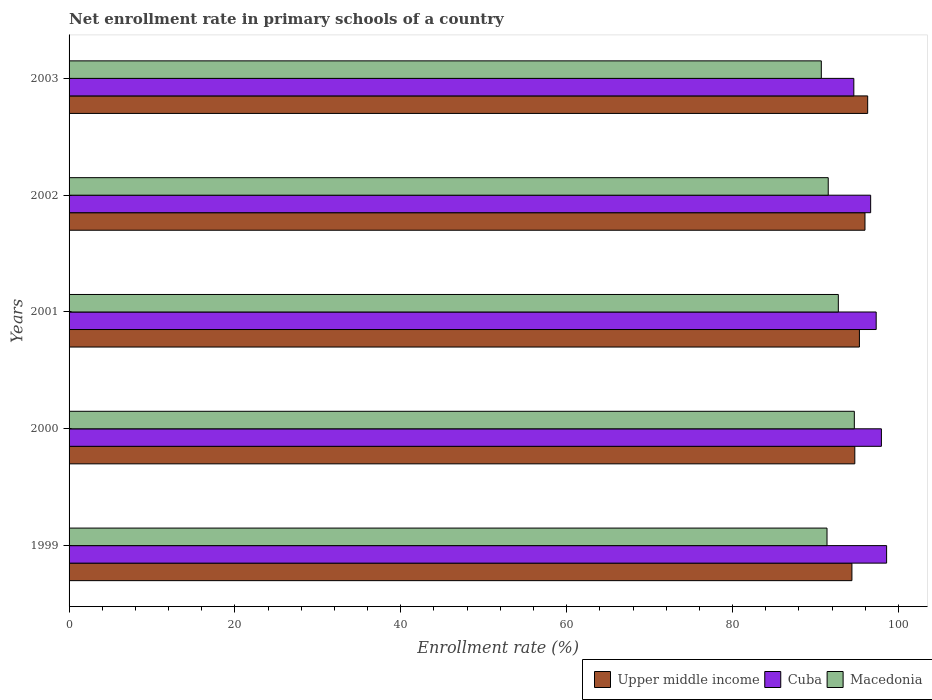How many different coloured bars are there?
Your response must be concise. 3. Are the number of bars per tick equal to the number of legend labels?
Your response must be concise. Yes. How many bars are there on the 3rd tick from the top?
Your response must be concise. 3. How many bars are there on the 4th tick from the bottom?
Ensure brevity in your answer.  3. What is the enrollment rate in primary schools in Macedonia in 2002?
Keep it short and to the point. 91.54. Across all years, what is the maximum enrollment rate in primary schools in Cuba?
Your response must be concise. 98.58. Across all years, what is the minimum enrollment rate in primary schools in Cuba?
Offer a very short reply. 94.62. In which year was the enrollment rate in primary schools in Upper middle income maximum?
Ensure brevity in your answer.  2003. In which year was the enrollment rate in primary schools in Cuba minimum?
Provide a succinct answer. 2003. What is the total enrollment rate in primary schools in Cuba in the graph?
Your response must be concise. 485.12. What is the difference between the enrollment rate in primary schools in Macedonia in 2001 and that in 2003?
Your response must be concise. 2.05. What is the difference between the enrollment rate in primary schools in Macedonia in 2000 and the enrollment rate in primary schools in Cuba in 2002?
Give a very brief answer. -1.97. What is the average enrollment rate in primary schools in Cuba per year?
Your answer should be very brief. 97.02. In the year 2001, what is the difference between the enrollment rate in primary schools in Macedonia and enrollment rate in primary schools in Cuba?
Provide a short and direct response. -4.57. In how many years, is the enrollment rate in primary schools in Macedonia greater than 64 %?
Offer a terse response. 5. What is the ratio of the enrollment rate in primary schools in Upper middle income in 2002 to that in 2003?
Your response must be concise. 1. Is the difference between the enrollment rate in primary schools in Macedonia in 1999 and 2001 greater than the difference between the enrollment rate in primary schools in Cuba in 1999 and 2001?
Your response must be concise. No. What is the difference between the highest and the second highest enrollment rate in primary schools in Macedonia?
Your answer should be very brief. 1.93. What is the difference between the highest and the lowest enrollment rate in primary schools in Macedonia?
Your response must be concise. 3.98. Is the sum of the enrollment rate in primary schools in Upper middle income in 2000 and 2002 greater than the maximum enrollment rate in primary schools in Cuba across all years?
Give a very brief answer. Yes. What does the 2nd bar from the top in 1999 represents?
Give a very brief answer. Cuba. What does the 1st bar from the bottom in 2003 represents?
Give a very brief answer. Upper middle income. How many bars are there?
Keep it short and to the point. 15. Are all the bars in the graph horizontal?
Ensure brevity in your answer.  Yes. What is the difference between two consecutive major ticks on the X-axis?
Offer a terse response. 20. Does the graph contain any zero values?
Your answer should be compact. No. Does the graph contain grids?
Your answer should be compact. No. Where does the legend appear in the graph?
Make the answer very short. Bottom right. What is the title of the graph?
Your answer should be compact. Net enrollment rate in primary schools of a country. Does "Middle income" appear as one of the legend labels in the graph?
Provide a succinct answer. No. What is the label or title of the X-axis?
Provide a succinct answer. Enrollment rate (%). What is the label or title of the Y-axis?
Your response must be concise. Years. What is the Enrollment rate (%) of Upper middle income in 1999?
Your response must be concise. 94.39. What is the Enrollment rate (%) of Cuba in 1999?
Make the answer very short. 98.58. What is the Enrollment rate (%) in Macedonia in 1999?
Provide a succinct answer. 91.39. What is the Enrollment rate (%) in Upper middle income in 2000?
Provide a short and direct response. 94.74. What is the Enrollment rate (%) of Cuba in 2000?
Give a very brief answer. 97.95. What is the Enrollment rate (%) in Macedonia in 2000?
Offer a very short reply. 94.68. What is the Enrollment rate (%) of Upper middle income in 2001?
Your answer should be very brief. 95.3. What is the Enrollment rate (%) of Cuba in 2001?
Your answer should be compact. 97.32. What is the Enrollment rate (%) in Macedonia in 2001?
Provide a short and direct response. 92.75. What is the Enrollment rate (%) of Upper middle income in 2002?
Make the answer very short. 95.97. What is the Enrollment rate (%) in Cuba in 2002?
Offer a very short reply. 96.65. What is the Enrollment rate (%) in Macedonia in 2002?
Give a very brief answer. 91.54. What is the Enrollment rate (%) of Upper middle income in 2003?
Ensure brevity in your answer.  96.29. What is the Enrollment rate (%) in Cuba in 2003?
Your response must be concise. 94.62. What is the Enrollment rate (%) in Macedonia in 2003?
Make the answer very short. 90.7. Across all years, what is the maximum Enrollment rate (%) in Upper middle income?
Offer a very short reply. 96.29. Across all years, what is the maximum Enrollment rate (%) in Cuba?
Give a very brief answer. 98.58. Across all years, what is the maximum Enrollment rate (%) in Macedonia?
Make the answer very short. 94.68. Across all years, what is the minimum Enrollment rate (%) of Upper middle income?
Ensure brevity in your answer.  94.39. Across all years, what is the minimum Enrollment rate (%) in Cuba?
Your answer should be very brief. 94.62. Across all years, what is the minimum Enrollment rate (%) of Macedonia?
Make the answer very short. 90.7. What is the total Enrollment rate (%) of Upper middle income in the graph?
Your answer should be very brief. 476.7. What is the total Enrollment rate (%) of Cuba in the graph?
Your answer should be compact. 485.12. What is the total Enrollment rate (%) in Macedonia in the graph?
Your answer should be compact. 461.07. What is the difference between the Enrollment rate (%) in Upper middle income in 1999 and that in 2000?
Give a very brief answer. -0.35. What is the difference between the Enrollment rate (%) in Cuba in 1999 and that in 2000?
Offer a very short reply. 0.63. What is the difference between the Enrollment rate (%) of Macedonia in 1999 and that in 2000?
Give a very brief answer. -3.29. What is the difference between the Enrollment rate (%) in Upper middle income in 1999 and that in 2001?
Offer a terse response. -0.9. What is the difference between the Enrollment rate (%) in Cuba in 1999 and that in 2001?
Your answer should be compact. 1.26. What is the difference between the Enrollment rate (%) of Macedonia in 1999 and that in 2001?
Offer a very short reply. -1.36. What is the difference between the Enrollment rate (%) in Upper middle income in 1999 and that in 2002?
Your answer should be very brief. -1.58. What is the difference between the Enrollment rate (%) of Cuba in 1999 and that in 2002?
Make the answer very short. 1.92. What is the difference between the Enrollment rate (%) of Macedonia in 1999 and that in 2002?
Give a very brief answer. -0.15. What is the difference between the Enrollment rate (%) of Upper middle income in 1999 and that in 2003?
Your answer should be compact. -1.9. What is the difference between the Enrollment rate (%) in Cuba in 1999 and that in 2003?
Make the answer very short. 3.95. What is the difference between the Enrollment rate (%) in Macedonia in 1999 and that in 2003?
Offer a very short reply. 0.69. What is the difference between the Enrollment rate (%) of Upper middle income in 2000 and that in 2001?
Your answer should be compact. -0.55. What is the difference between the Enrollment rate (%) in Cuba in 2000 and that in 2001?
Make the answer very short. 0.63. What is the difference between the Enrollment rate (%) of Macedonia in 2000 and that in 2001?
Provide a short and direct response. 1.93. What is the difference between the Enrollment rate (%) in Upper middle income in 2000 and that in 2002?
Your answer should be compact. -1.23. What is the difference between the Enrollment rate (%) of Cuba in 2000 and that in 2002?
Provide a short and direct response. 1.29. What is the difference between the Enrollment rate (%) in Macedonia in 2000 and that in 2002?
Your answer should be compact. 3.15. What is the difference between the Enrollment rate (%) of Upper middle income in 2000 and that in 2003?
Your response must be concise. -1.55. What is the difference between the Enrollment rate (%) of Cuba in 2000 and that in 2003?
Offer a terse response. 3.33. What is the difference between the Enrollment rate (%) in Macedonia in 2000 and that in 2003?
Offer a terse response. 3.98. What is the difference between the Enrollment rate (%) in Upper middle income in 2001 and that in 2002?
Make the answer very short. -0.67. What is the difference between the Enrollment rate (%) of Cuba in 2001 and that in 2002?
Provide a succinct answer. 0.67. What is the difference between the Enrollment rate (%) in Macedonia in 2001 and that in 2002?
Your response must be concise. 1.22. What is the difference between the Enrollment rate (%) in Upper middle income in 2001 and that in 2003?
Provide a succinct answer. -1. What is the difference between the Enrollment rate (%) in Cuba in 2001 and that in 2003?
Keep it short and to the point. 2.7. What is the difference between the Enrollment rate (%) in Macedonia in 2001 and that in 2003?
Keep it short and to the point. 2.05. What is the difference between the Enrollment rate (%) in Upper middle income in 2002 and that in 2003?
Make the answer very short. -0.32. What is the difference between the Enrollment rate (%) of Cuba in 2002 and that in 2003?
Offer a very short reply. 2.03. What is the difference between the Enrollment rate (%) of Macedonia in 2002 and that in 2003?
Provide a short and direct response. 0.83. What is the difference between the Enrollment rate (%) of Upper middle income in 1999 and the Enrollment rate (%) of Cuba in 2000?
Offer a very short reply. -3.55. What is the difference between the Enrollment rate (%) in Upper middle income in 1999 and the Enrollment rate (%) in Macedonia in 2000?
Keep it short and to the point. -0.29. What is the difference between the Enrollment rate (%) in Cuba in 1999 and the Enrollment rate (%) in Macedonia in 2000?
Give a very brief answer. 3.89. What is the difference between the Enrollment rate (%) in Upper middle income in 1999 and the Enrollment rate (%) in Cuba in 2001?
Your answer should be very brief. -2.93. What is the difference between the Enrollment rate (%) of Upper middle income in 1999 and the Enrollment rate (%) of Macedonia in 2001?
Your answer should be very brief. 1.64. What is the difference between the Enrollment rate (%) of Cuba in 1999 and the Enrollment rate (%) of Macedonia in 2001?
Make the answer very short. 5.82. What is the difference between the Enrollment rate (%) in Upper middle income in 1999 and the Enrollment rate (%) in Cuba in 2002?
Provide a succinct answer. -2.26. What is the difference between the Enrollment rate (%) of Upper middle income in 1999 and the Enrollment rate (%) of Macedonia in 2002?
Offer a very short reply. 2.86. What is the difference between the Enrollment rate (%) of Cuba in 1999 and the Enrollment rate (%) of Macedonia in 2002?
Your answer should be very brief. 7.04. What is the difference between the Enrollment rate (%) of Upper middle income in 1999 and the Enrollment rate (%) of Cuba in 2003?
Make the answer very short. -0.23. What is the difference between the Enrollment rate (%) in Upper middle income in 1999 and the Enrollment rate (%) in Macedonia in 2003?
Provide a succinct answer. 3.69. What is the difference between the Enrollment rate (%) in Cuba in 1999 and the Enrollment rate (%) in Macedonia in 2003?
Make the answer very short. 7.87. What is the difference between the Enrollment rate (%) in Upper middle income in 2000 and the Enrollment rate (%) in Cuba in 2001?
Provide a short and direct response. -2.58. What is the difference between the Enrollment rate (%) of Upper middle income in 2000 and the Enrollment rate (%) of Macedonia in 2001?
Provide a succinct answer. 1.99. What is the difference between the Enrollment rate (%) of Cuba in 2000 and the Enrollment rate (%) of Macedonia in 2001?
Your answer should be very brief. 5.19. What is the difference between the Enrollment rate (%) in Upper middle income in 2000 and the Enrollment rate (%) in Cuba in 2002?
Your answer should be compact. -1.91. What is the difference between the Enrollment rate (%) in Upper middle income in 2000 and the Enrollment rate (%) in Macedonia in 2002?
Provide a short and direct response. 3.21. What is the difference between the Enrollment rate (%) of Cuba in 2000 and the Enrollment rate (%) of Macedonia in 2002?
Provide a succinct answer. 6.41. What is the difference between the Enrollment rate (%) in Upper middle income in 2000 and the Enrollment rate (%) in Cuba in 2003?
Keep it short and to the point. 0.12. What is the difference between the Enrollment rate (%) of Upper middle income in 2000 and the Enrollment rate (%) of Macedonia in 2003?
Offer a terse response. 4.04. What is the difference between the Enrollment rate (%) in Cuba in 2000 and the Enrollment rate (%) in Macedonia in 2003?
Your response must be concise. 7.24. What is the difference between the Enrollment rate (%) in Upper middle income in 2001 and the Enrollment rate (%) in Cuba in 2002?
Offer a very short reply. -1.36. What is the difference between the Enrollment rate (%) in Upper middle income in 2001 and the Enrollment rate (%) in Macedonia in 2002?
Provide a succinct answer. 3.76. What is the difference between the Enrollment rate (%) in Cuba in 2001 and the Enrollment rate (%) in Macedonia in 2002?
Provide a succinct answer. 5.78. What is the difference between the Enrollment rate (%) of Upper middle income in 2001 and the Enrollment rate (%) of Cuba in 2003?
Your answer should be compact. 0.67. What is the difference between the Enrollment rate (%) of Upper middle income in 2001 and the Enrollment rate (%) of Macedonia in 2003?
Your answer should be compact. 4.59. What is the difference between the Enrollment rate (%) of Cuba in 2001 and the Enrollment rate (%) of Macedonia in 2003?
Make the answer very short. 6.62. What is the difference between the Enrollment rate (%) of Upper middle income in 2002 and the Enrollment rate (%) of Cuba in 2003?
Your answer should be compact. 1.35. What is the difference between the Enrollment rate (%) in Upper middle income in 2002 and the Enrollment rate (%) in Macedonia in 2003?
Ensure brevity in your answer.  5.27. What is the difference between the Enrollment rate (%) in Cuba in 2002 and the Enrollment rate (%) in Macedonia in 2003?
Ensure brevity in your answer.  5.95. What is the average Enrollment rate (%) in Upper middle income per year?
Provide a succinct answer. 95.34. What is the average Enrollment rate (%) of Cuba per year?
Your answer should be compact. 97.02. What is the average Enrollment rate (%) in Macedonia per year?
Provide a short and direct response. 92.21. In the year 1999, what is the difference between the Enrollment rate (%) of Upper middle income and Enrollment rate (%) of Cuba?
Provide a succinct answer. -4.18. In the year 1999, what is the difference between the Enrollment rate (%) of Upper middle income and Enrollment rate (%) of Macedonia?
Give a very brief answer. 3. In the year 1999, what is the difference between the Enrollment rate (%) of Cuba and Enrollment rate (%) of Macedonia?
Your answer should be very brief. 7.19. In the year 2000, what is the difference between the Enrollment rate (%) in Upper middle income and Enrollment rate (%) in Cuba?
Your response must be concise. -3.21. In the year 2000, what is the difference between the Enrollment rate (%) in Upper middle income and Enrollment rate (%) in Macedonia?
Offer a terse response. 0.06. In the year 2000, what is the difference between the Enrollment rate (%) of Cuba and Enrollment rate (%) of Macedonia?
Offer a very short reply. 3.26. In the year 2001, what is the difference between the Enrollment rate (%) of Upper middle income and Enrollment rate (%) of Cuba?
Make the answer very short. -2.02. In the year 2001, what is the difference between the Enrollment rate (%) of Upper middle income and Enrollment rate (%) of Macedonia?
Offer a terse response. 2.54. In the year 2001, what is the difference between the Enrollment rate (%) of Cuba and Enrollment rate (%) of Macedonia?
Your answer should be very brief. 4.57. In the year 2002, what is the difference between the Enrollment rate (%) of Upper middle income and Enrollment rate (%) of Cuba?
Offer a very short reply. -0.68. In the year 2002, what is the difference between the Enrollment rate (%) in Upper middle income and Enrollment rate (%) in Macedonia?
Offer a very short reply. 4.43. In the year 2002, what is the difference between the Enrollment rate (%) of Cuba and Enrollment rate (%) of Macedonia?
Offer a very short reply. 5.12. In the year 2003, what is the difference between the Enrollment rate (%) of Upper middle income and Enrollment rate (%) of Cuba?
Provide a short and direct response. 1.67. In the year 2003, what is the difference between the Enrollment rate (%) in Upper middle income and Enrollment rate (%) in Macedonia?
Provide a short and direct response. 5.59. In the year 2003, what is the difference between the Enrollment rate (%) in Cuba and Enrollment rate (%) in Macedonia?
Offer a terse response. 3.92. What is the ratio of the Enrollment rate (%) of Upper middle income in 1999 to that in 2000?
Your answer should be very brief. 1. What is the ratio of the Enrollment rate (%) in Cuba in 1999 to that in 2000?
Give a very brief answer. 1.01. What is the ratio of the Enrollment rate (%) in Macedonia in 1999 to that in 2000?
Ensure brevity in your answer.  0.97. What is the ratio of the Enrollment rate (%) in Upper middle income in 1999 to that in 2001?
Offer a very short reply. 0.99. What is the ratio of the Enrollment rate (%) in Cuba in 1999 to that in 2001?
Your answer should be very brief. 1.01. What is the ratio of the Enrollment rate (%) of Upper middle income in 1999 to that in 2002?
Ensure brevity in your answer.  0.98. What is the ratio of the Enrollment rate (%) in Cuba in 1999 to that in 2002?
Make the answer very short. 1.02. What is the ratio of the Enrollment rate (%) of Macedonia in 1999 to that in 2002?
Provide a succinct answer. 1. What is the ratio of the Enrollment rate (%) of Upper middle income in 1999 to that in 2003?
Give a very brief answer. 0.98. What is the ratio of the Enrollment rate (%) of Cuba in 1999 to that in 2003?
Give a very brief answer. 1.04. What is the ratio of the Enrollment rate (%) of Macedonia in 1999 to that in 2003?
Keep it short and to the point. 1.01. What is the ratio of the Enrollment rate (%) in Upper middle income in 2000 to that in 2001?
Make the answer very short. 0.99. What is the ratio of the Enrollment rate (%) of Macedonia in 2000 to that in 2001?
Your answer should be compact. 1.02. What is the ratio of the Enrollment rate (%) of Upper middle income in 2000 to that in 2002?
Your response must be concise. 0.99. What is the ratio of the Enrollment rate (%) in Cuba in 2000 to that in 2002?
Offer a very short reply. 1.01. What is the ratio of the Enrollment rate (%) in Macedonia in 2000 to that in 2002?
Give a very brief answer. 1.03. What is the ratio of the Enrollment rate (%) in Upper middle income in 2000 to that in 2003?
Keep it short and to the point. 0.98. What is the ratio of the Enrollment rate (%) of Cuba in 2000 to that in 2003?
Keep it short and to the point. 1.04. What is the ratio of the Enrollment rate (%) of Macedonia in 2000 to that in 2003?
Offer a terse response. 1.04. What is the ratio of the Enrollment rate (%) in Upper middle income in 2001 to that in 2002?
Provide a succinct answer. 0.99. What is the ratio of the Enrollment rate (%) in Macedonia in 2001 to that in 2002?
Provide a succinct answer. 1.01. What is the ratio of the Enrollment rate (%) of Cuba in 2001 to that in 2003?
Your answer should be compact. 1.03. What is the ratio of the Enrollment rate (%) in Macedonia in 2001 to that in 2003?
Offer a terse response. 1.02. What is the ratio of the Enrollment rate (%) of Upper middle income in 2002 to that in 2003?
Provide a succinct answer. 1. What is the ratio of the Enrollment rate (%) of Cuba in 2002 to that in 2003?
Your answer should be very brief. 1.02. What is the ratio of the Enrollment rate (%) of Macedonia in 2002 to that in 2003?
Offer a terse response. 1.01. What is the difference between the highest and the second highest Enrollment rate (%) in Upper middle income?
Your answer should be compact. 0.32. What is the difference between the highest and the second highest Enrollment rate (%) in Cuba?
Provide a succinct answer. 0.63. What is the difference between the highest and the second highest Enrollment rate (%) in Macedonia?
Ensure brevity in your answer.  1.93. What is the difference between the highest and the lowest Enrollment rate (%) of Cuba?
Ensure brevity in your answer.  3.95. What is the difference between the highest and the lowest Enrollment rate (%) of Macedonia?
Offer a terse response. 3.98. 